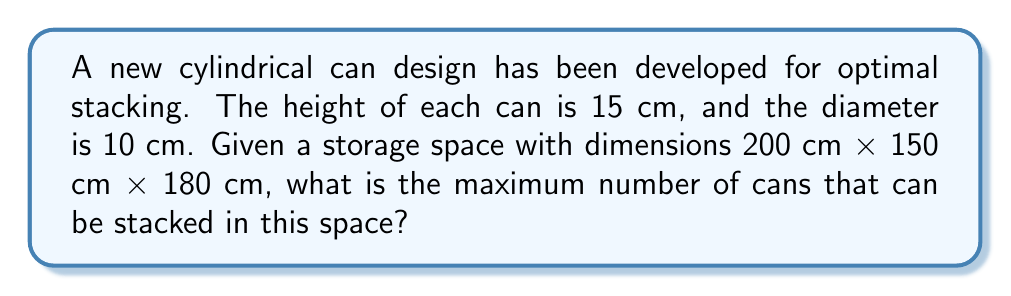Give your solution to this math problem. To solve this problem, we need to follow these steps:

1. Calculate the number of cans that can fit along each dimension of the storage space.

2. Multiply these numbers to get the total number of cans.

For the length (200 cm):
$$ \text{Number of cans} = \left\lfloor\frac{200 \text{ cm}}{10 \text{ cm}}\right\rfloor = 20 $$

For the width (150 cm):
$$ \text{Number of cans} = \left\lfloor\frac{150 \text{ cm}}{10 \text{ cm}}\right\rfloor = 15 $$

For the height (180 cm):
$$ \text{Number of cans} = \left\lfloor\frac{180 \text{ cm}}{15 \text{ cm}}\right\rfloor = 12 $$

The floor function $\lfloor \cdot \rfloor$ is used because we can only have whole numbers of cans.

3. Calculate the total number of cans:

$$ \text{Total cans} = 20 \times 15 \times 12 = 3,600 $$

Therefore, the maximum number of cans that can be stacked in the given storage space is 3,600.

[asy]
unitsize(0.5cm);
draw((0,0)--(20,0)--(20,15)--(0,15)--cycle);
draw((0,0)--(5,5)--(25,5)--(20,0));
draw((20,15)--(25,20)--(25,5));
draw((0,15)--(5,20)--(25,20));
label("200 cm", (10,-1));
label("150 cm", (-1,7.5));
label("180 cm", (26,12.5));
for(int i=0; i<20; ++i) {
  for(int j=0; j<15; ++j) {
    draw(circle((i+0.5,j+0.5),0.5));
  }
}
[/asy]
Answer: 3,600 cans 